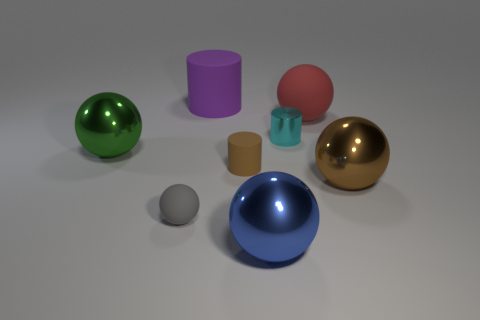Subtract all green balls. How many balls are left? 4 Subtract 1 balls. How many balls are left? 4 Subtract all gray balls. How many balls are left? 4 Subtract all brown spheres. Subtract all cyan cylinders. How many spheres are left? 4 Add 2 brown rubber cylinders. How many objects exist? 10 Subtract all spheres. How many objects are left? 3 Add 6 red objects. How many red objects are left? 7 Add 6 yellow metal objects. How many yellow metal objects exist? 6 Subtract 1 blue balls. How many objects are left? 7 Subtract all tiny cyan shiny things. Subtract all large red things. How many objects are left? 6 